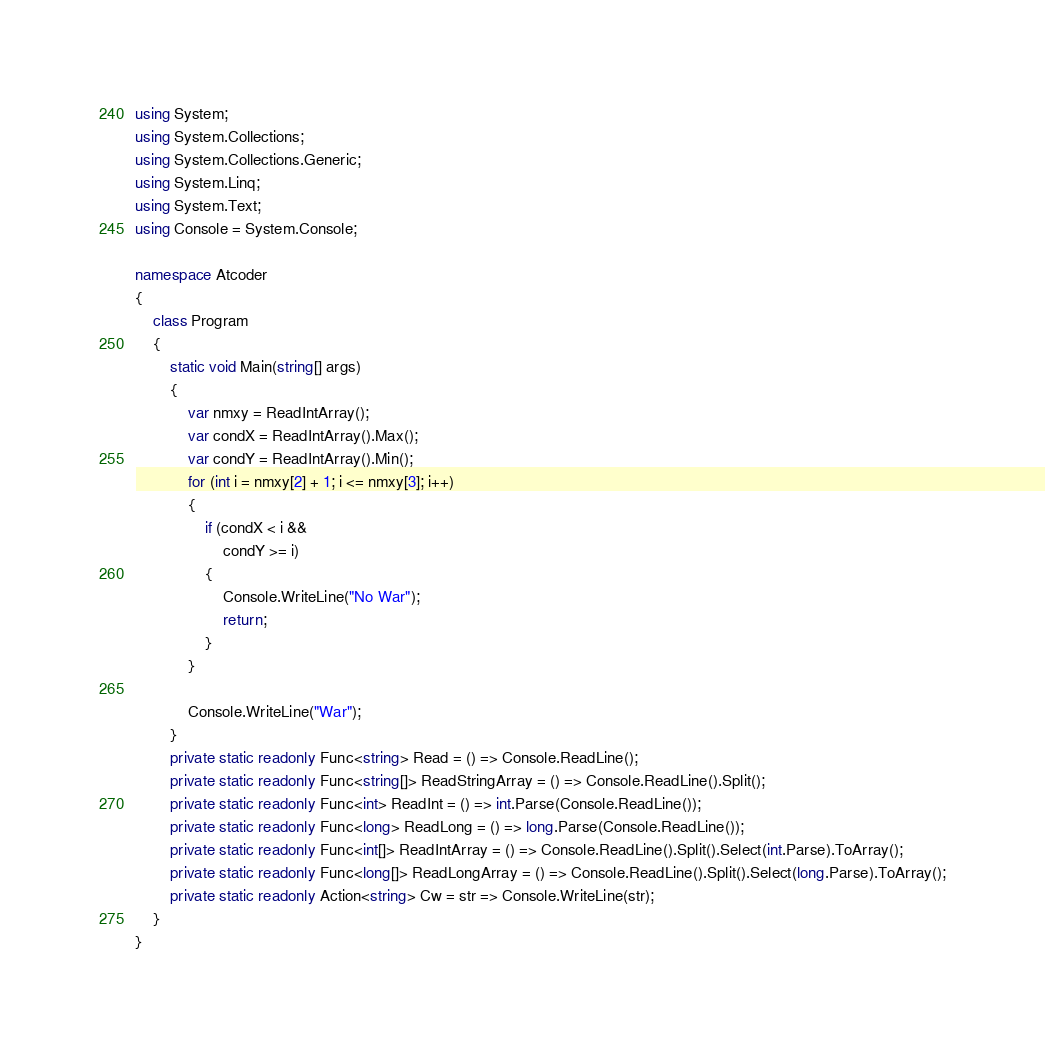<code> <loc_0><loc_0><loc_500><loc_500><_C#_>using System;
using System.Collections;
using System.Collections.Generic;
using System.Linq;
using System.Text;
using Console = System.Console;

namespace Atcoder
{
    class Program
    {
        static void Main(string[] args)
        {
            var nmxy = ReadIntArray();
            var condX = ReadIntArray().Max();
            var condY = ReadIntArray().Min();
            for (int i = nmxy[2] + 1; i <= nmxy[3]; i++)
            {
                if (condX < i &&
                    condY >= i)
                {
                    Console.WriteLine("No War");
                    return;
                }
            }

            Console.WriteLine("War");
        }
        private static readonly Func<string> Read = () => Console.ReadLine();
        private static readonly Func<string[]> ReadStringArray = () => Console.ReadLine().Split();
        private static readonly Func<int> ReadInt = () => int.Parse(Console.ReadLine());
        private static readonly Func<long> ReadLong = () => long.Parse(Console.ReadLine());
        private static readonly Func<int[]> ReadIntArray = () => Console.ReadLine().Split().Select(int.Parse).ToArray();
        private static readonly Func<long[]> ReadLongArray = () => Console.ReadLine().Split().Select(long.Parse).ToArray();
        private static readonly Action<string> Cw = str => Console.WriteLine(str);
    }
}</code> 